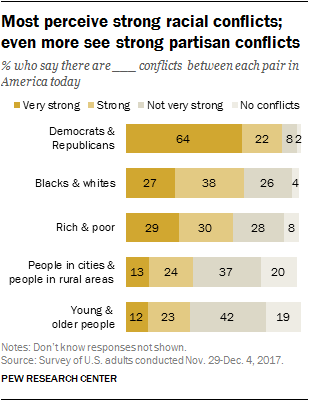Identify some key points in this picture. The ratio between very strong and no conflicts in Rich & Poor is approximately 1.213888889. The category of "rich & poor" can be identified based on the given values of 29, 30, 28, and 8. 